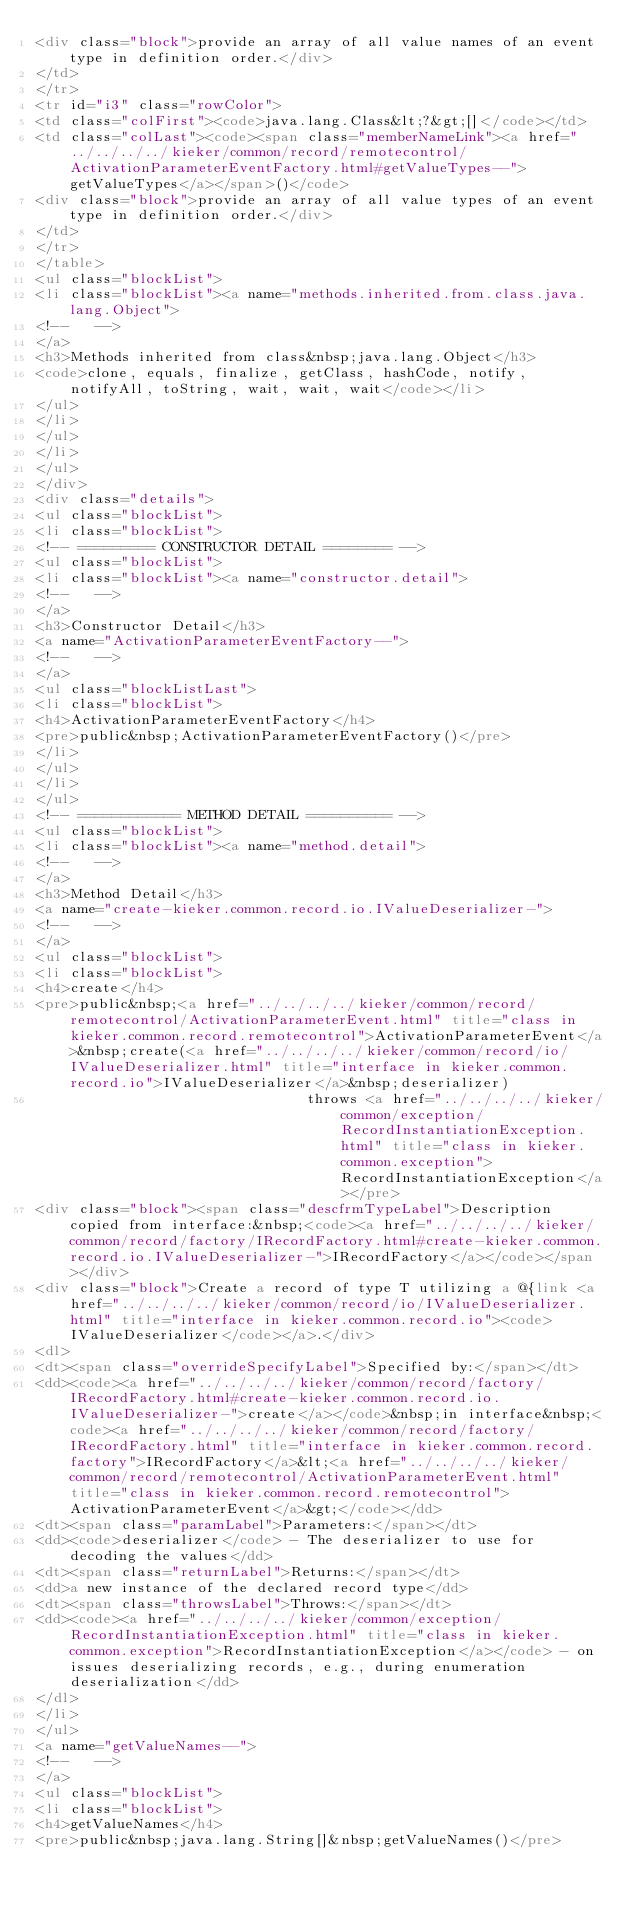<code> <loc_0><loc_0><loc_500><loc_500><_HTML_><div class="block">provide an array of all value names of an event type in definition order.</div>
</td>
</tr>
<tr id="i3" class="rowColor">
<td class="colFirst"><code>java.lang.Class&lt;?&gt;[]</code></td>
<td class="colLast"><code><span class="memberNameLink"><a href="../../../../kieker/common/record/remotecontrol/ActivationParameterEventFactory.html#getValueTypes--">getValueTypes</a></span>()</code>
<div class="block">provide an array of all value types of an event type in definition order.</div>
</td>
</tr>
</table>
<ul class="blockList">
<li class="blockList"><a name="methods.inherited.from.class.java.lang.Object">
<!--   -->
</a>
<h3>Methods inherited from class&nbsp;java.lang.Object</h3>
<code>clone, equals, finalize, getClass, hashCode, notify, notifyAll, toString, wait, wait, wait</code></li>
</ul>
</li>
</ul>
</li>
</ul>
</div>
<div class="details">
<ul class="blockList">
<li class="blockList">
<!-- ========= CONSTRUCTOR DETAIL ======== -->
<ul class="blockList">
<li class="blockList"><a name="constructor.detail">
<!--   -->
</a>
<h3>Constructor Detail</h3>
<a name="ActivationParameterEventFactory--">
<!--   -->
</a>
<ul class="blockListLast">
<li class="blockList">
<h4>ActivationParameterEventFactory</h4>
<pre>public&nbsp;ActivationParameterEventFactory()</pre>
</li>
</ul>
</li>
</ul>
<!-- ============ METHOD DETAIL ========== -->
<ul class="blockList">
<li class="blockList"><a name="method.detail">
<!--   -->
</a>
<h3>Method Detail</h3>
<a name="create-kieker.common.record.io.IValueDeserializer-">
<!--   -->
</a>
<ul class="blockList">
<li class="blockList">
<h4>create</h4>
<pre>public&nbsp;<a href="../../../../kieker/common/record/remotecontrol/ActivationParameterEvent.html" title="class in kieker.common.record.remotecontrol">ActivationParameterEvent</a>&nbsp;create(<a href="../../../../kieker/common/record/io/IValueDeserializer.html" title="interface in kieker.common.record.io">IValueDeserializer</a>&nbsp;deserializer)
                                throws <a href="../../../../kieker/common/exception/RecordInstantiationException.html" title="class in kieker.common.exception">RecordInstantiationException</a></pre>
<div class="block"><span class="descfrmTypeLabel">Description copied from interface:&nbsp;<code><a href="../../../../kieker/common/record/factory/IRecordFactory.html#create-kieker.common.record.io.IValueDeserializer-">IRecordFactory</a></code></span></div>
<div class="block">Create a record of type T utilizing a @{link <a href="../../../../kieker/common/record/io/IValueDeserializer.html" title="interface in kieker.common.record.io"><code>IValueDeserializer</code></a>.</div>
<dl>
<dt><span class="overrideSpecifyLabel">Specified by:</span></dt>
<dd><code><a href="../../../../kieker/common/record/factory/IRecordFactory.html#create-kieker.common.record.io.IValueDeserializer-">create</a></code>&nbsp;in interface&nbsp;<code><a href="../../../../kieker/common/record/factory/IRecordFactory.html" title="interface in kieker.common.record.factory">IRecordFactory</a>&lt;<a href="../../../../kieker/common/record/remotecontrol/ActivationParameterEvent.html" title="class in kieker.common.record.remotecontrol">ActivationParameterEvent</a>&gt;</code></dd>
<dt><span class="paramLabel">Parameters:</span></dt>
<dd><code>deserializer</code> - The deserializer to use for decoding the values</dd>
<dt><span class="returnLabel">Returns:</span></dt>
<dd>a new instance of the declared record type</dd>
<dt><span class="throwsLabel">Throws:</span></dt>
<dd><code><a href="../../../../kieker/common/exception/RecordInstantiationException.html" title="class in kieker.common.exception">RecordInstantiationException</a></code> - on issues deserializing records, e.g., during enumeration deserialization</dd>
</dl>
</li>
</ul>
<a name="getValueNames--">
<!--   -->
</a>
<ul class="blockList">
<li class="blockList">
<h4>getValueNames</h4>
<pre>public&nbsp;java.lang.String[]&nbsp;getValueNames()</pre></code> 